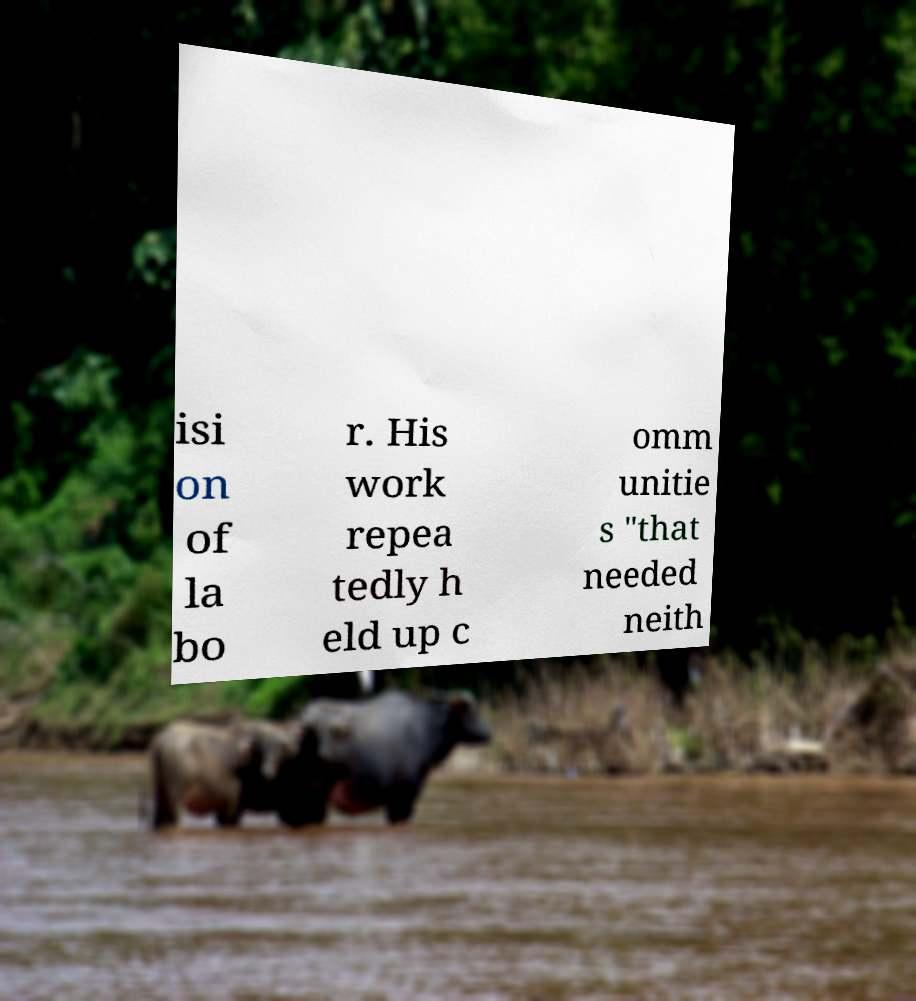I need the written content from this picture converted into text. Can you do that? isi on of la bo r. His work repea tedly h eld up c omm unitie s "that needed neith 